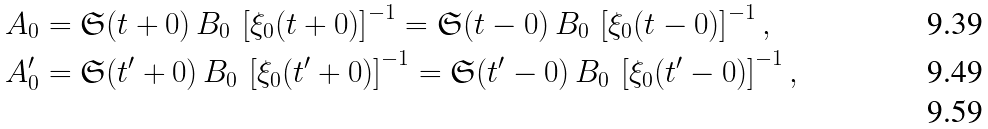Convert formula to latex. <formula><loc_0><loc_0><loc_500><loc_500>A _ { 0 } & = \mathfrak { S } ( t + 0 ) \, B _ { 0 } \, \left [ \xi _ { 0 } ( t + 0 ) \right ] ^ { - 1 } = \mathfrak { S } ( t - 0 ) \, B _ { 0 } \, \left [ \xi _ { 0 } ( t - 0 ) \right ] ^ { - 1 } , \\ A ^ { \prime } _ { 0 } & = \mathfrak { S } ( t ^ { \prime } + 0 ) \, B _ { 0 } \, \left [ \xi _ { 0 } ( t ^ { \prime } + 0 ) \right ] ^ { - 1 } = \mathfrak { S } ( t ^ { \prime } - 0 ) \, B _ { 0 } \, \left [ \xi _ { 0 } ( t ^ { \prime } - 0 ) \right ] ^ { - 1 } , \\</formula> 